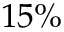Convert formula to latex. <formula><loc_0><loc_0><loc_500><loc_500>1 5 \%</formula> 